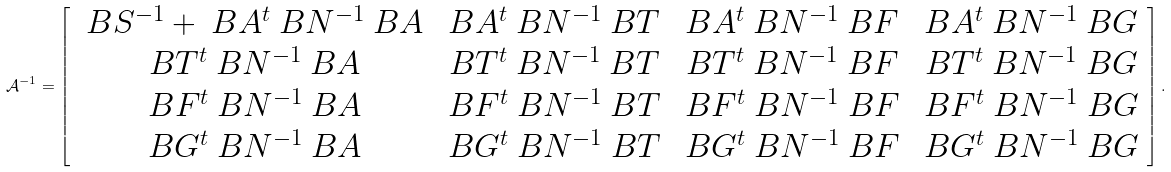Convert formula to latex. <formula><loc_0><loc_0><loc_500><loc_500>\mathcal { A } ^ { - 1 } = \left [ \begin{array} { c c c c } \ B S ^ { - 1 } + \ B A ^ { t } \ B N ^ { - 1 } \ B A & \ B A ^ { t } \ B N ^ { - 1 } \ B T & \ B A ^ { t } \ B N ^ { - 1 } \ B F & \ B A ^ { t } \ B N ^ { - 1 } \ B G \\ \ B T ^ { t } \ B N ^ { - 1 } \ B A & \ B T ^ { t } \ B N ^ { - 1 } \ B T & \ B T ^ { t } \ B N ^ { - 1 } \ B F & \ B T ^ { t } \ B N ^ { - 1 } \ B G \\ \ B F ^ { t } \ B N ^ { - 1 } \ B A & \ B F ^ { t } \ B N ^ { - 1 } \ B T & \ B F ^ { t } \ B N ^ { - 1 } \ B F & \ B F ^ { t } \ B N ^ { - 1 } \ B G \\ \ B G ^ { t } \ B N ^ { - 1 } \ B A & \ B G ^ { t } \ B N ^ { - 1 } \ B T & \ B G ^ { t } \ B N ^ { - 1 } \ B F & \ B G ^ { t } \ B N ^ { - 1 } \ B G \end{array} \right ] .</formula> 